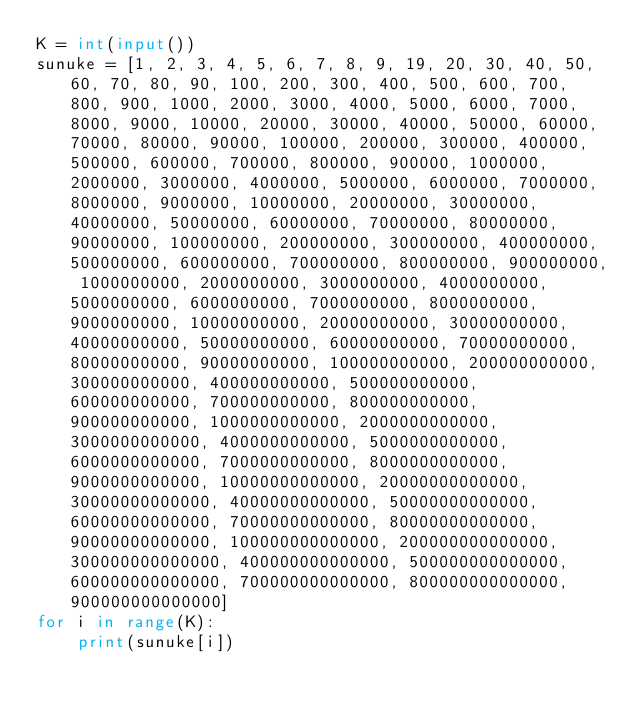<code> <loc_0><loc_0><loc_500><loc_500><_Python_>K = int(input())
sunuke = [1, 2, 3, 4, 5, 6, 7, 8, 9, 19, 20, 30, 40, 50, 60, 70, 80, 90, 100, 200, 300, 400, 500, 600, 700, 800, 900, 1000, 2000, 3000, 4000, 5000, 6000, 7000, 8000, 9000, 10000, 20000, 30000, 40000, 50000, 60000, 70000, 80000, 90000, 100000, 200000, 300000, 400000, 500000, 600000, 700000, 800000, 900000, 1000000, 2000000, 3000000, 4000000, 5000000, 6000000, 7000000, 8000000, 9000000, 10000000, 20000000, 30000000, 40000000, 50000000, 60000000, 70000000, 80000000, 90000000, 100000000, 200000000, 300000000, 400000000, 500000000, 600000000, 700000000, 800000000, 900000000, 1000000000, 2000000000, 3000000000, 4000000000, 5000000000, 6000000000, 7000000000, 8000000000, 9000000000, 10000000000, 20000000000, 30000000000, 40000000000, 50000000000, 60000000000, 70000000000, 80000000000, 90000000000, 100000000000, 200000000000, 300000000000, 400000000000, 500000000000, 600000000000, 700000000000, 800000000000, 900000000000, 1000000000000, 2000000000000, 3000000000000, 4000000000000, 5000000000000, 6000000000000, 7000000000000, 8000000000000, 9000000000000, 10000000000000, 20000000000000, 30000000000000, 40000000000000, 50000000000000, 60000000000000, 70000000000000, 80000000000000, 90000000000000, 100000000000000, 200000000000000, 300000000000000, 400000000000000, 500000000000000, 600000000000000, 700000000000000, 800000000000000, 900000000000000]
for i in range(K):
    print(sunuke[i])
</code> 